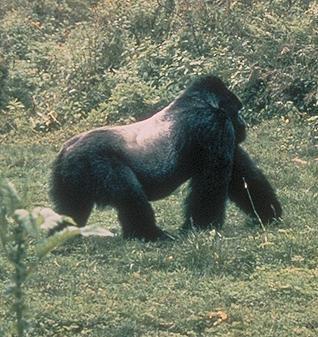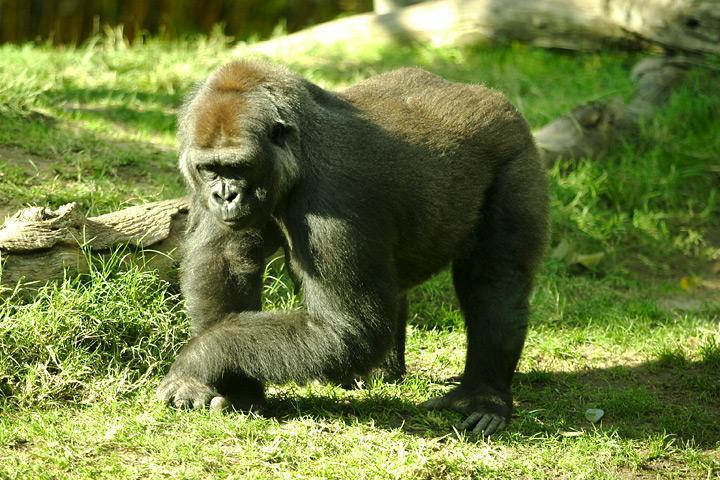The first image is the image on the left, the second image is the image on the right. Given the left and right images, does the statement "The right image contains one gorilla standing upright on two legs." hold true? Answer yes or no. No. The first image is the image on the left, the second image is the image on the right. For the images shown, is this caption "An ape is standing on two legs." true? Answer yes or no. No. 